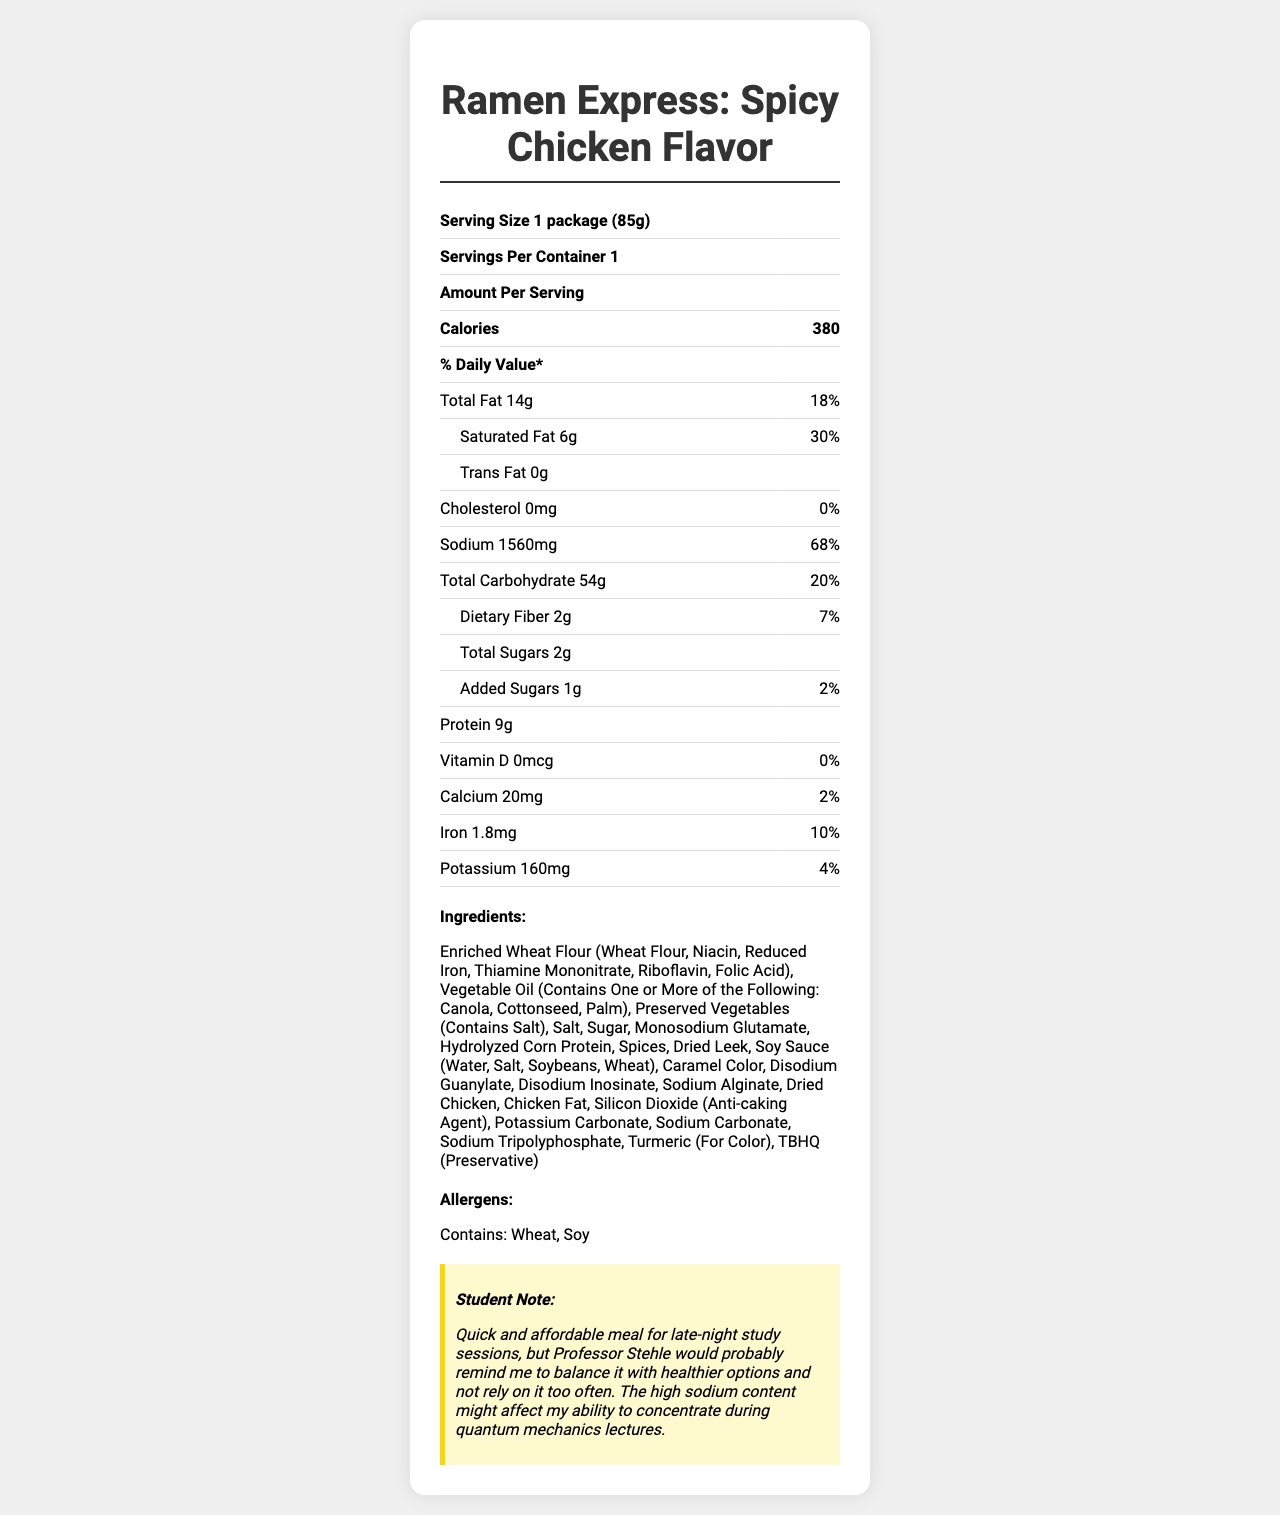what is the serving size? The serving size listed at the top of the document indicates "Serving Size 1 package (85g)".
Answer: 1 package (85g) what is the amount of saturated fat in one serving? Under the Total Fat section, the sub-item Saturated Fat is listed with an amount of 6g.
Answer: 6g what percentage of the daily value is the sodium content? The Sodium section lists the sodium content as 68% of the daily value.
Answer: 68% how much protein is in the entire package? The Protein section lists the amount of protein in one serving as 9g, and since there is one serving per container, it applies to the entire package.
Answer: 9g what is the student note about this product? The Student Note section at the bottom contains this specific piece of text.
Answer: Quick and affordable meal for late-night study sessions, but Professor Stehle would probably remind me to balance it with healthier options and not rely on it too often. The high sodium content might affect my ability to concentrate during quantum mechanics lectures. which vitamins and minerals have a daily value of 0% in this product? A. Vitamin D and Calcium B. Iron and Potassium C. Sodium and Cholesterol D. Vitamin D and Cholesterol Both Vitamin D and Cholesterol have a daily value of 0%, which can be seen in their respective sections.
Answer: D which substances are listed under Ingredients? (Select all that apply) A. Riboflavin B. Monosodium Glutamate C. Hydrolyzed Corn Protein D. Sodium Carbonate All these substances are listed under the Ingredients section.
Answer: A, B, C, and D does this product contain any allergens? The Allergens section mentions that the product contains Wheat and Soy.
Answer: Yes is there any cholesterol in this product? The Cholesterol section lists the amount as 0mg and the daily value as 0%.
Answer: No summarize the key nutritional data of this product. The summary captures the serving size, major nutritional values, allergens, and a brief mention of the student note.
Answer: The "Ramen Express: Spicy Chicken Flavor" instant noodles have a serving size of 1 package (85g) with 380 calories per serving. The total fat is 14g (18% DV), saturated fat is 6g (30% DV), and there is 0g trans fat. The noodles contain 0mg of cholesterol (0% DV) and 1560mg of sodium (68% DV). The total carbohydrates are 54g (20% DV), including 2g of dietary fiber (7% DV) and 2g total sugars (1g added sugars, 2% DV). It has 9g of protein. Additionally, it provides 0% DV of vitamin D, 2% DV of calcium, 10% DV of iron, and 4% DV of potassium. The product contains wheat and soy allergens and has a student's note advising balance due to high sodium content. how long might it take to prepare this product in a microwave? The document does not provide information regarding the preparation time or method for the product.
Answer: Cannot be determined 